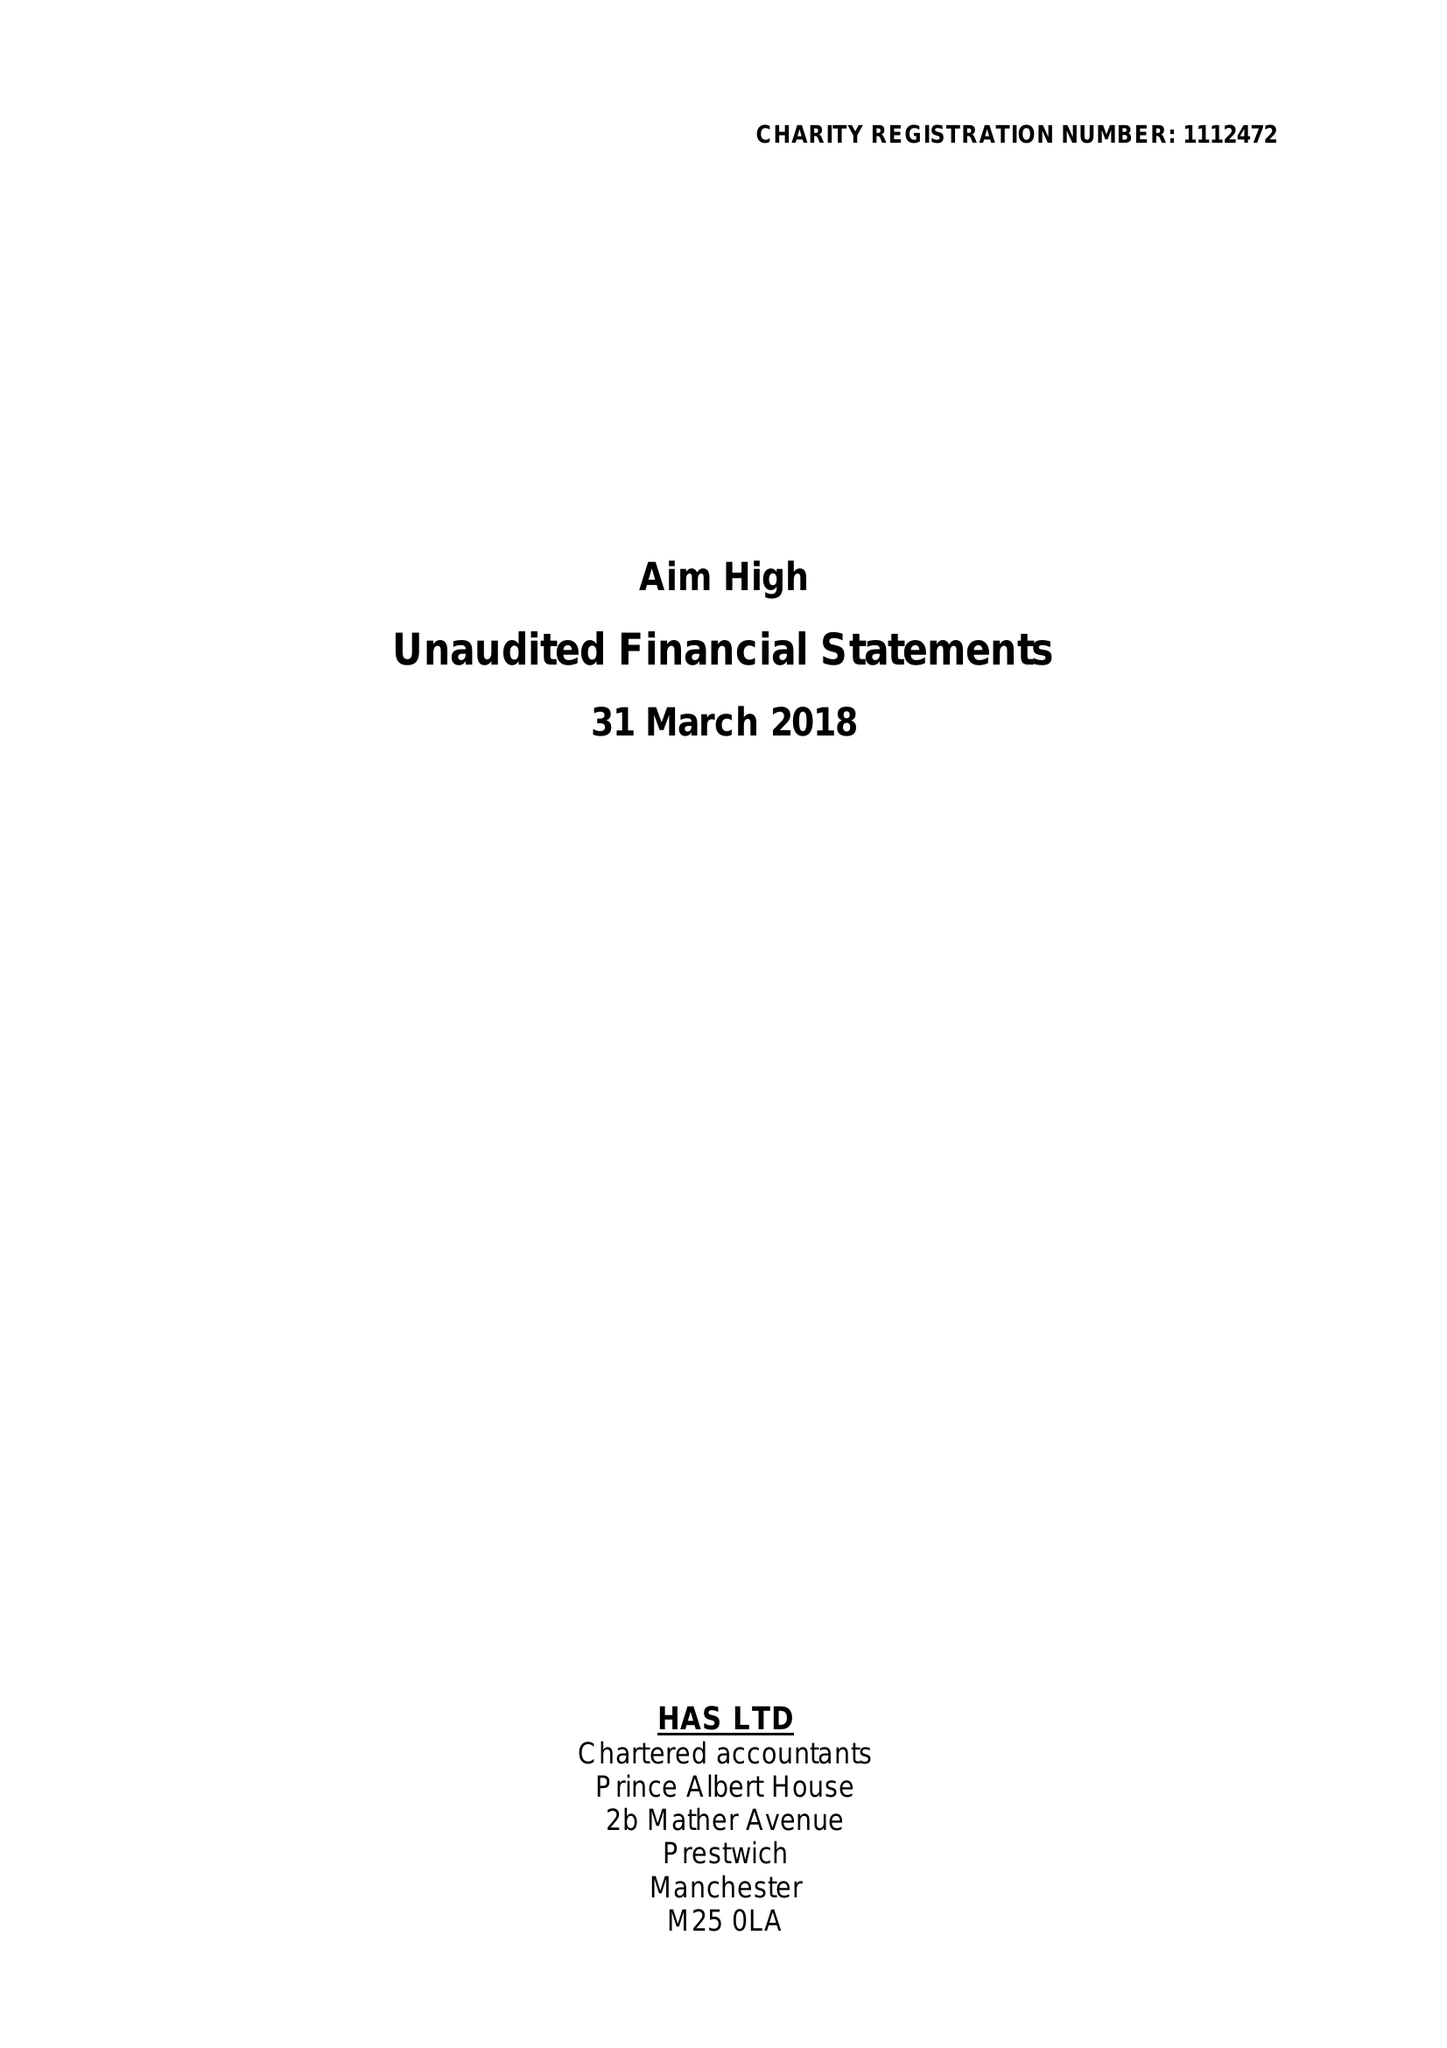What is the value for the address__post_town?
Answer the question using a single word or phrase. MANCHESTER 